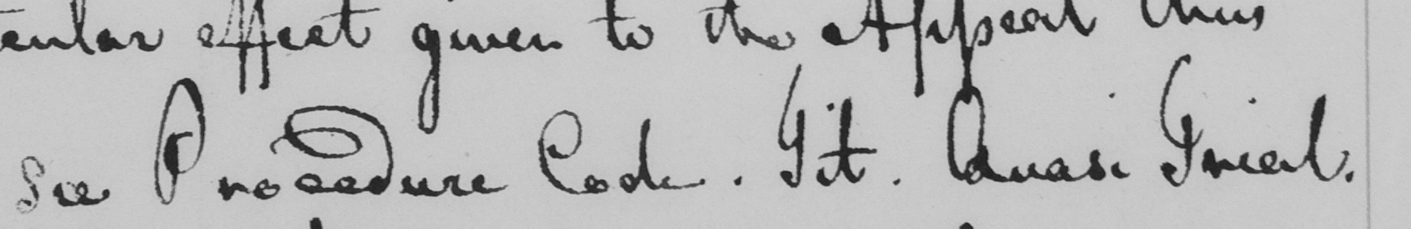Can you tell me what this handwritten text says? see Procedure Code . Tit . Quasi Trial . 